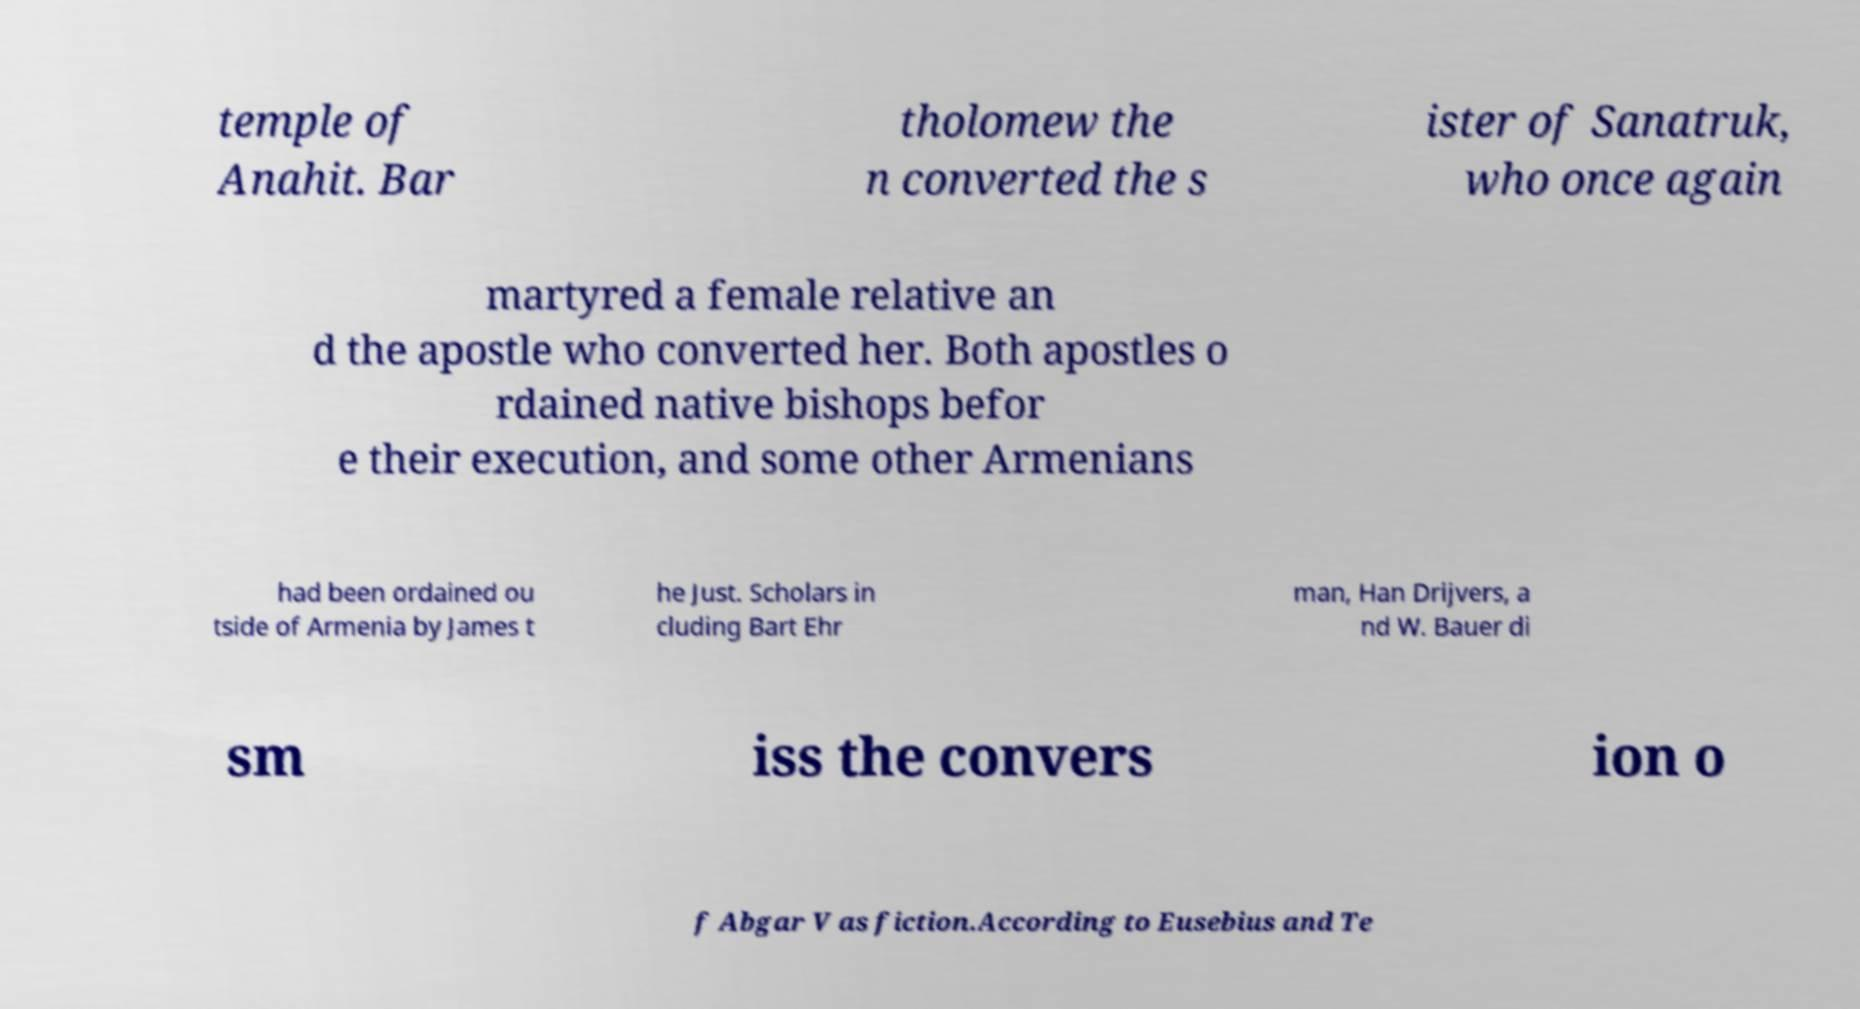What messages or text are displayed in this image? I need them in a readable, typed format. temple of Anahit. Bar tholomew the n converted the s ister of Sanatruk, who once again martyred a female relative an d the apostle who converted her. Both apostles o rdained native bishops befor e their execution, and some other Armenians had been ordained ou tside of Armenia by James t he Just. Scholars in cluding Bart Ehr man, Han Drijvers, a nd W. Bauer di sm iss the convers ion o f Abgar V as fiction.According to Eusebius and Te 